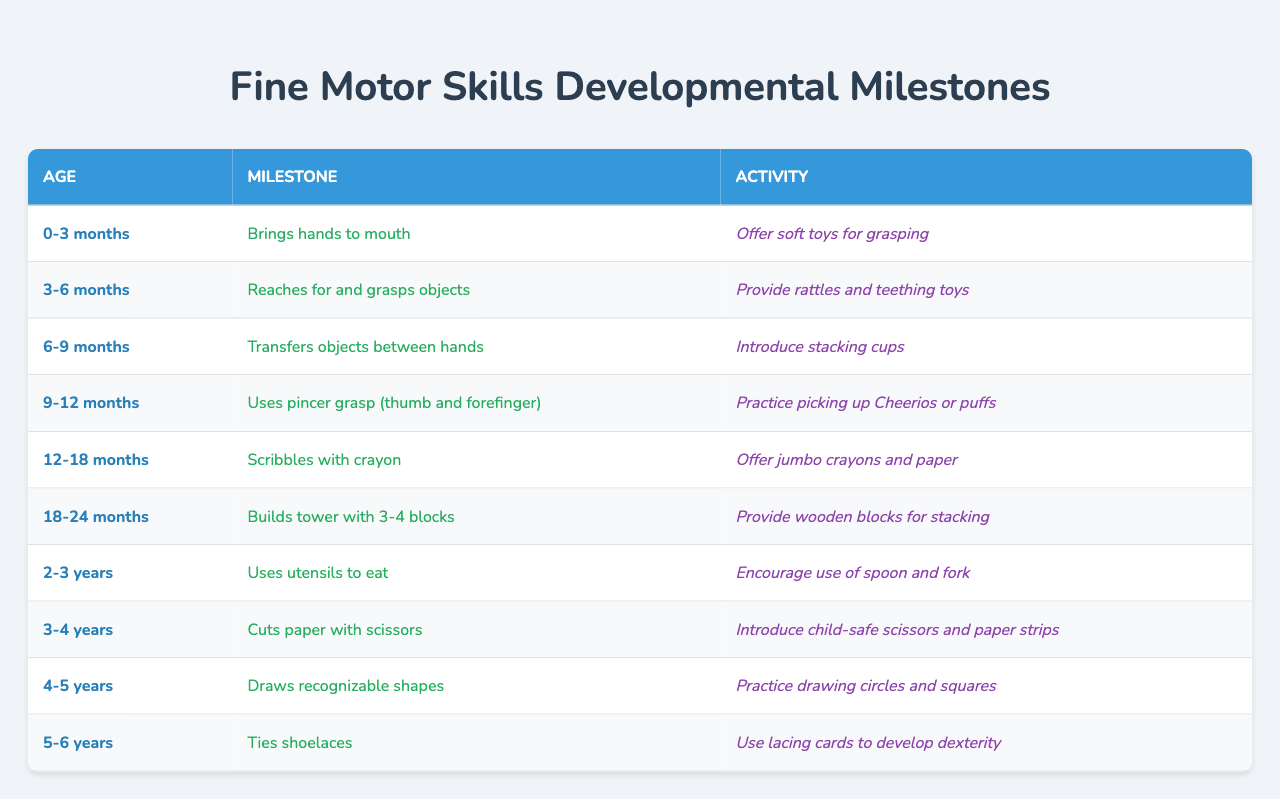What fine motor skill milestone occurs at 6-9 months? The milestone for the age group 6-9 months is "Transfers objects between hands," which is stated in the table.
Answer: Transfers objects between hands What activity can help a child develop skills at 12-18 months? For the age group of 12-18 months, the activity to promote development is "Offer jumbo crayons and paper," as referenced in the table under that age.
Answer: Offer jumbo crayons and paper At what age does a child typically start using a pincer grasp? According to the table, the pincer grasp (using the thumb and forefinger) is typically developed between 9-12 months.
Answer: 9-12 months How many blocks should a child be able to stack by 18-24 months? The table indicates that by 18-24 months, a child should be able to build a tower with 3-4 blocks.
Answer: 3-4 blocks Is it true that children can draw recognizable shapes by age 5? Yes, the table states that at age 4-5 years, children can draw recognizable shapes, confirming this fact.
Answer: Yes Which activity is suggested for developing fine motor skills at 3-4 years? The table lists "Introduce child-safe scissors and paper strips" as the suggested activity for fine motor skills at the age of 3-4 years.
Answer: Introduce child-safe scissors and paper strips What is the milestone for 2-3 years regarding utensil use? The milestone for 2-3 years is that children "Use utensils to eat," as shown in the table.
Answer: Use utensils to eat How many milestones are listed in the table for children aged 0-6 years? There are 10 milestones listed for ages 0-6 years, as indicated by the various entries in the provided table.
Answer: 10 milestones What milestone indicates that a child is 5-6 years old regarding shoe tying? The table states that at 5-6 years, the milestone is "Ties shoelaces." This indicates the ability at that age.
Answer: Ties shoelaces Compare the activities suggested for children aged 0-3 months and 2-3 years. What are the main differences? For 0-3 months, the activity is "Offer soft toys for grasping," while for 2-3 years, it's "Encourage use of spoon and fork." This shows a progression from simple grasping to using utensils.
Answer: Different focuses on simple grasping vs. using utensils 